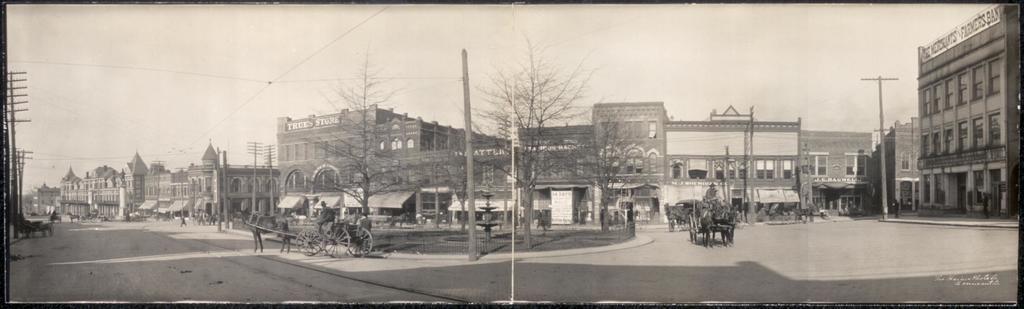In one or two sentences, can you explain what this image depicts? In the center of the image we can see fountain, trees, grass, a pole and a horse cart. On the right side of the image we can see buildings, horse cart, trees, poles, persons and road. On the left side of the image we can see buildings, poles, road and persons. In the background there is a sky. 